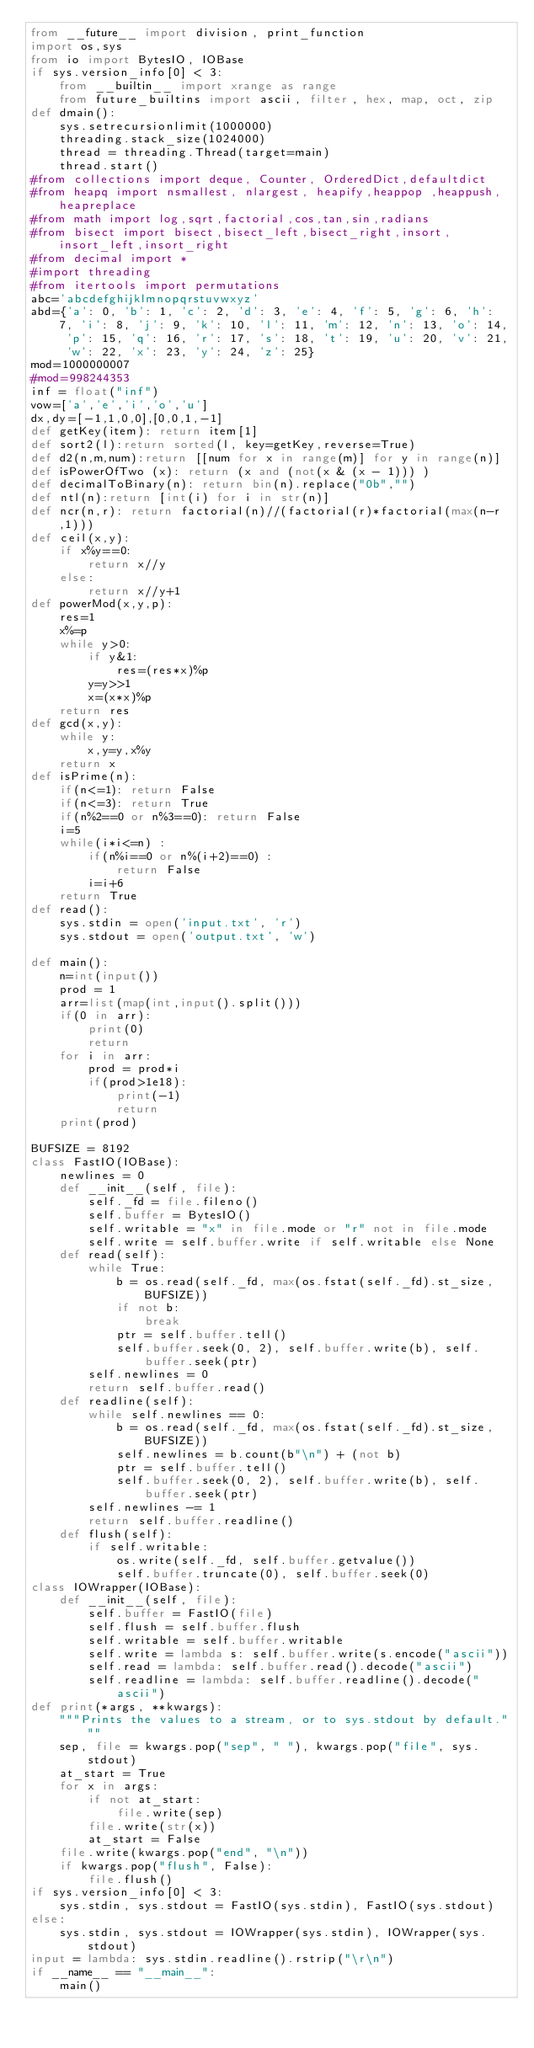Convert code to text. <code><loc_0><loc_0><loc_500><loc_500><_Python_>from __future__ import division, print_function
import os,sys
from io import BytesIO, IOBase
if sys.version_info[0] < 3:
    from __builtin__ import xrange as range
    from future_builtins import ascii, filter, hex, map, oct, zip
def dmain():
    sys.setrecursionlimit(1000000)
    threading.stack_size(1024000)
    thread = threading.Thread(target=main)
    thread.start()
#from collections import deque, Counter, OrderedDict,defaultdict
#from heapq import nsmallest, nlargest, heapify,heappop ,heappush, heapreplace
#from math import log,sqrt,factorial,cos,tan,sin,radians
#from bisect import bisect,bisect_left,bisect_right,insort,insort_left,insort_right
#from decimal import *
#import threading
#from itertools import permutations
abc='abcdefghijklmnopqrstuvwxyz'
abd={'a': 0, 'b': 1, 'c': 2, 'd': 3, 'e': 4, 'f': 5, 'g': 6, 'h': 7, 'i': 8, 'j': 9, 'k': 10, 'l': 11, 'm': 12, 'n': 13, 'o': 14, 'p': 15, 'q': 16, 'r': 17, 's': 18, 't': 19, 'u': 20, 'v': 21, 'w': 22, 'x': 23, 'y': 24, 'z': 25}
mod=1000000007
#mod=998244353
inf = float("inf")
vow=['a','e','i','o','u']
dx,dy=[-1,1,0,0],[0,0,1,-1]
def getKey(item): return item[1] 
def sort2(l):return sorted(l, key=getKey,reverse=True)
def d2(n,m,num):return [[num for x in range(m)] for y in range(n)]
def isPowerOfTwo (x): return (x and (not(x & (x - 1))) )
def decimalToBinary(n): return bin(n).replace("0b","")
def ntl(n):return [int(i) for i in str(n)]
def ncr(n,r): return factorial(n)//(factorial(r)*factorial(max(n-r,1)))
def ceil(x,y):
    if x%y==0:
        return x//y
    else:
        return x//y+1
def powerMod(x,y,p):
    res=1
    x%=p
    while y>0:
        if y&1:
            res=(res*x)%p
        y=y>>1
        x=(x*x)%p
    return res
def gcd(x,y):
    while y:
        x,y=y,x%y
    return x
def isPrime(n):
    if(n<=1): return False
    if(n<=3): return True
    if(n%2==0 or n%3==0): return False
    i=5
    while(i*i<=n) : 
        if(n%i==0 or n%(i+2)==0) : 
            return False
        i=i+6
    return True
def read():
    sys.stdin = open('input.txt', 'r')  
    sys.stdout = open('output.txt', 'w') 

def main():
    n=int(input())
    prod = 1
    arr=list(map(int,input().split()))
    if(0 in arr):
        print(0)
        return
    for i in arr:
        prod = prod*i
        if(prod>1e18):
            print(-1)
            return
    print(prod)

BUFSIZE = 8192
class FastIO(IOBase):
    newlines = 0
    def __init__(self, file):
        self._fd = file.fileno()
        self.buffer = BytesIO()
        self.writable = "x" in file.mode or "r" not in file.mode
        self.write = self.buffer.write if self.writable else None
    def read(self):
        while True:
            b = os.read(self._fd, max(os.fstat(self._fd).st_size, BUFSIZE))
            if not b:
                break
            ptr = self.buffer.tell()
            self.buffer.seek(0, 2), self.buffer.write(b), self.buffer.seek(ptr)
        self.newlines = 0
        return self.buffer.read()
    def readline(self):
        while self.newlines == 0:
            b = os.read(self._fd, max(os.fstat(self._fd).st_size, BUFSIZE))
            self.newlines = b.count(b"\n") + (not b)
            ptr = self.buffer.tell()
            self.buffer.seek(0, 2), self.buffer.write(b), self.buffer.seek(ptr)
        self.newlines -= 1
        return self.buffer.readline()
    def flush(self):
        if self.writable:
            os.write(self._fd, self.buffer.getvalue())
            self.buffer.truncate(0), self.buffer.seek(0)
class IOWrapper(IOBase):
    def __init__(self, file):
        self.buffer = FastIO(file)
        self.flush = self.buffer.flush
        self.writable = self.buffer.writable
        self.write = lambda s: self.buffer.write(s.encode("ascii"))
        self.read = lambda: self.buffer.read().decode("ascii")
        self.readline = lambda: self.buffer.readline().decode("ascii")
def print(*args, **kwargs):
    """Prints the values to a stream, or to sys.stdout by default."""
    sep, file = kwargs.pop("sep", " "), kwargs.pop("file", sys.stdout)
    at_start = True
    for x in args:
        if not at_start:
            file.write(sep)
        file.write(str(x))
        at_start = False
    file.write(kwargs.pop("end", "\n"))
    if kwargs.pop("flush", False):
        file.flush()
if sys.version_info[0] < 3:
    sys.stdin, sys.stdout = FastIO(sys.stdin), FastIO(sys.stdout)
else:
    sys.stdin, sys.stdout = IOWrapper(sys.stdin), IOWrapper(sys.stdout)
input = lambda: sys.stdin.readline().rstrip("\r\n")
if __name__ == "__main__":
    main()</code> 